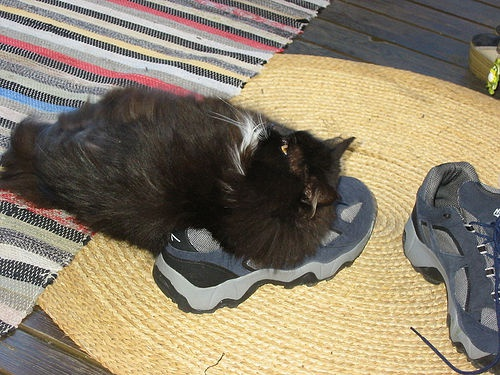Describe the objects in this image and their specific colors. I can see a cat in gray and black tones in this image. 